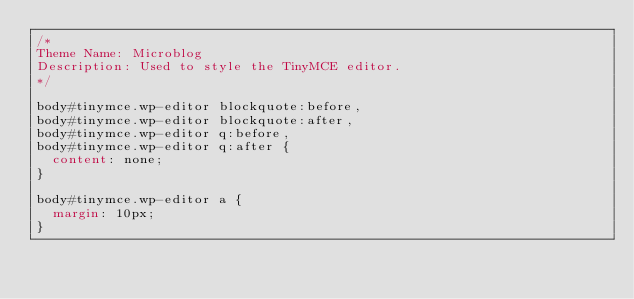<code> <loc_0><loc_0><loc_500><loc_500><_CSS_>/*
Theme Name: Microblog
Description: Used to style the TinyMCE editor.
*/

body#tinymce.wp-editor blockquote:before,
body#tinymce.wp-editor blockquote:after,
body#tinymce.wp-editor q:before,
body#tinymce.wp-editor q:after {
	content: none;
}

body#tinymce.wp-editor a {
	margin: 10px;
}</code> 